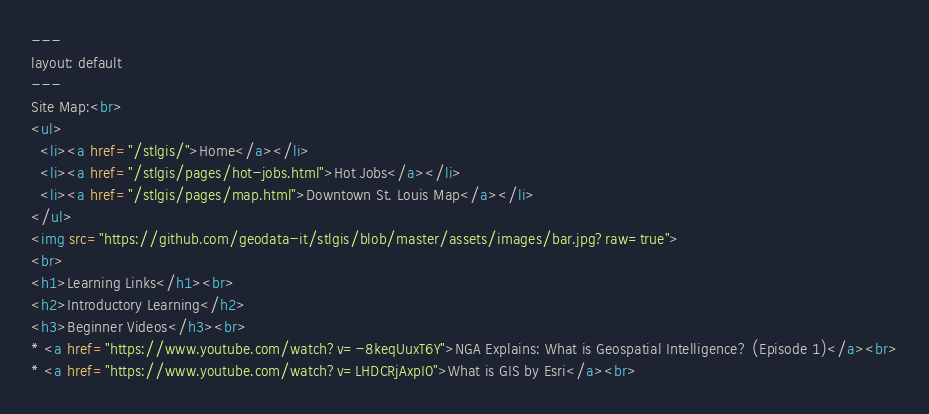Convert code to text. <code><loc_0><loc_0><loc_500><loc_500><_HTML_>---
layout: default
---
Site Map:<br>
<ul>
  <li><a href="/stlgis/">Home</a></li>
  <li><a href="/stlgis/pages/hot-jobs.html">Hot Jobs</a></li>
  <li><a href="/stlgis/pages/map.html">Downtown St. Louis Map</a></li>
</ul>
<img src="https://github.com/geodata-it/stlgis/blob/master/assets/images/bar.jpg?raw=true">
<br>
<h1>Learning Links</h1><br>
<h2>Introductory Learning</h2>
<h3>Beginner Videos</h3><br>
* <a href="https://www.youtube.com/watch?v=-8keqUuxT6Y">NGA Explains: What is Geospatial Intelligence? (Episode 1)</a><br>
* <a href="https://www.youtube.com/watch?v=LHDCRjAxpI0">What is GIS by Esri</a><br></code> 